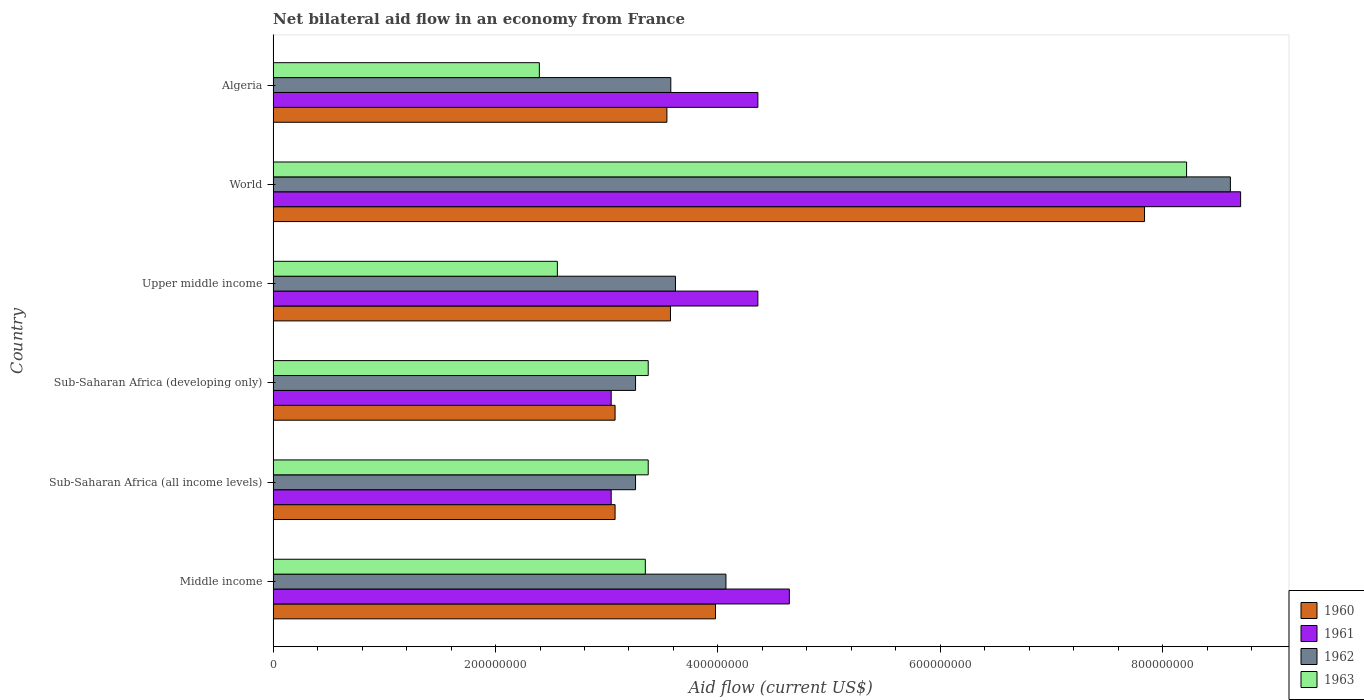How many bars are there on the 6th tick from the top?
Offer a very short reply. 4. How many bars are there on the 5th tick from the bottom?
Keep it short and to the point. 4. In how many cases, is the number of bars for a given country not equal to the number of legend labels?
Your response must be concise. 0. What is the net bilateral aid flow in 1960 in World?
Provide a succinct answer. 7.84e+08. Across all countries, what is the maximum net bilateral aid flow in 1963?
Offer a terse response. 8.21e+08. Across all countries, what is the minimum net bilateral aid flow in 1961?
Your response must be concise. 3.04e+08. In which country was the net bilateral aid flow in 1961 maximum?
Offer a terse response. World. In which country was the net bilateral aid flow in 1962 minimum?
Offer a very short reply. Sub-Saharan Africa (all income levels). What is the total net bilateral aid flow in 1962 in the graph?
Keep it short and to the point. 2.64e+09. What is the difference between the net bilateral aid flow in 1963 in Algeria and that in Upper middle income?
Your response must be concise. -1.62e+07. What is the difference between the net bilateral aid flow in 1960 in Sub-Saharan Africa (all income levels) and the net bilateral aid flow in 1962 in Middle income?
Offer a very short reply. -9.97e+07. What is the average net bilateral aid flow in 1962 per country?
Give a very brief answer. 4.40e+08. What is the difference between the net bilateral aid flow in 1960 and net bilateral aid flow in 1963 in Sub-Saharan Africa (all income levels)?
Your answer should be very brief. -2.98e+07. In how many countries, is the net bilateral aid flow in 1962 greater than 160000000 US$?
Make the answer very short. 6. What is the ratio of the net bilateral aid flow in 1961 in Sub-Saharan Africa (developing only) to that in Upper middle income?
Provide a short and direct response. 0.7. Is the difference between the net bilateral aid flow in 1960 in Middle income and Sub-Saharan Africa (all income levels) greater than the difference between the net bilateral aid flow in 1963 in Middle income and Sub-Saharan Africa (all income levels)?
Provide a succinct answer. Yes. What is the difference between the highest and the second highest net bilateral aid flow in 1960?
Give a very brief answer. 3.86e+08. What is the difference between the highest and the lowest net bilateral aid flow in 1961?
Offer a terse response. 5.66e+08. Is the sum of the net bilateral aid flow in 1961 in Middle income and World greater than the maximum net bilateral aid flow in 1963 across all countries?
Your answer should be very brief. Yes. Is it the case that in every country, the sum of the net bilateral aid flow in 1962 and net bilateral aid flow in 1960 is greater than the sum of net bilateral aid flow in 1963 and net bilateral aid flow in 1961?
Offer a terse response. No. What does the 4th bar from the top in Middle income represents?
Provide a succinct answer. 1960. What does the 3rd bar from the bottom in Sub-Saharan Africa (developing only) represents?
Your answer should be very brief. 1962. Is it the case that in every country, the sum of the net bilateral aid flow in 1961 and net bilateral aid flow in 1962 is greater than the net bilateral aid flow in 1963?
Make the answer very short. Yes. Are all the bars in the graph horizontal?
Give a very brief answer. Yes. How many countries are there in the graph?
Your answer should be compact. 6. Does the graph contain any zero values?
Your answer should be very brief. No. Does the graph contain grids?
Make the answer very short. No. How many legend labels are there?
Offer a very short reply. 4. What is the title of the graph?
Provide a succinct answer. Net bilateral aid flow in an economy from France. Does "2009" appear as one of the legend labels in the graph?
Offer a terse response. No. What is the Aid flow (current US$) of 1960 in Middle income?
Keep it short and to the point. 3.98e+08. What is the Aid flow (current US$) in 1961 in Middle income?
Your response must be concise. 4.64e+08. What is the Aid flow (current US$) in 1962 in Middle income?
Offer a terse response. 4.07e+08. What is the Aid flow (current US$) of 1963 in Middle income?
Provide a short and direct response. 3.35e+08. What is the Aid flow (current US$) in 1960 in Sub-Saharan Africa (all income levels)?
Your answer should be very brief. 3.08e+08. What is the Aid flow (current US$) in 1961 in Sub-Saharan Africa (all income levels)?
Your answer should be compact. 3.04e+08. What is the Aid flow (current US$) in 1962 in Sub-Saharan Africa (all income levels)?
Make the answer very short. 3.26e+08. What is the Aid flow (current US$) in 1963 in Sub-Saharan Africa (all income levels)?
Your response must be concise. 3.37e+08. What is the Aid flow (current US$) in 1960 in Sub-Saharan Africa (developing only)?
Keep it short and to the point. 3.08e+08. What is the Aid flow (current US$) in 1961 in Sub-Saharan Africa (developing only)?
Offer a very short reply. 3.04e+08. What is the Aid flow (current US$) of 1962 in Sub-Saharan Africa (developing only)?
Provide a succinct answer. 3.26e+08. What is the Aid flow (current US$) in 1963 in Sub-Saharan Africa (developing only)?
Offer a very short reply. 3.37e+08. What is the Aid flow (current US$) of 1960 in Upper middle income?
Provide a short and direct response. 3.57e+08. What is the Aid flow (current US$) of 1961 in Upper middle income?
Provide a succinct answer. 4.36e+08. What is the Aid flow (current US$) of 1962 in Upper middle income?
Give a very brief answer. 3.62e+08. What is the Aid flow (current US$) in 1963 in Upper middle income?
Your answer should be very brief. 2.56e+08. What is the Aid flow (current US$) in 1960 in World?
Offer a terse response. 7.84e+08. What is the Aid flow (current US$) of 1961 in World?
Provide a succinct answer. 8.70e+08. What is the Aid flow (current US$) of 1962 in World?
Offer a very short reply. 8.61e+08. What is the Aid flow (current US$) of 1963 in World?
Offer a very short reply. 8.21e+08. What is the Aid flow (current US$) in 1960 in Algeria?
Ensure brevity in your answer.  3.54e+08. What is the Aid flow (current US$) in 1961 in Algeria?
Your answer should be very brief. 4.36e+08. What is the Aid flow (current US$) of 1962 in Algeria?
Give a very brief answer. 3.58e+08. What is the Aid flow (current US$) in 1963 in Algeria?
Keep it short and to the point. 2.39e+08. Across all countries, what is the maximum Aid flow (current US$) of 1960?
Your answer should be very brief. 7.84e+08. Across all countries, what is the maximum Aid flow (current US$) in 1961?
Your answer should be very brief. 8.70e+08. Across all countries, what is the maximum Aid flow (current US$) of 1962?
Your answer should be very brief. 8.61e+08. Across all countries, what is the maximum Aid flow (current US$) of 1963?
Your response must be concise. 8.21e+08. Across all countries, what is the minimum Aid flow (current US$) in 1960?
Offer a terse response. 3.08e+08. Across all countries, what is the minimum Aid flow (current US$) in 1961?
Your answer should be very brief. 3.04e+08. Across all countries, what is the minimum Aid flow (current US$) of 1962?
Make the answer very short. 3.26e+08. Across all countries, what is the minimum Aid flow (current US$) in 1963?
Keep it short and to the point. 2.39e+08. What is the total Aid flow (current US$) in 1960 in the graph?
Keep it short and to the point. 2.51e+09. What is the total Aid flow (current US$) in 1961 in the graph?
Offer a very short reply. 2.81e+09. What is the total Aid flow (current US$) of 1962 in the graph?
Your answer should be very brief. 2.64e+09. What is the total Aid flow (current US$) in 1963 in the graph?
Offer a terse response. 2.33e+09. What is the difference between the Aid flow (current US$) in 1960 in Middle income and that in Sub-Saharan Africa (all income levels)?
Give a very brief answer. 9.03e+07. What is the difference between the Aid flow (current US$) of 1961 in Middle income and that in Sub-Saharan Africa (all income levels)?
Offer a terse response. 1.60e+08. What is the difference between the Aid flow (current US$) of 1962 in Middle income and that in Sub-Saharan Africa (all income levels)?
Ensure brevity in your answer.  8.13e+07. What is the difference between the Aid flow (current US$) of 1963 in Middle income and that in Sub-Saharan Africa (all income levels)?
Offer a terse response. -2.60e+06. What is the difference between the Aid flow (current US$) of 1960 in Middle income and that in Sub-Saharan Africa (developing only)?
Your answer should be compact. 9.03e+07. What is the difference between the Aid flow (current US$) in 1961 in Middle income and that in Sub-Saharan Africa (developing only)?
Provide a short and direct response. 1.60e+08. What is the difference between the Aid flow (current US$) in 1962 in Middle income and that in Sub-Saharan Africa (developing only)?
Offer a terse response. 8.13e+07. What is the difference between the Aid flow (current US$) of 1963 in Middle income and that in Sub-Saharan Africa (developing only)?
Provide a succinct answer. -2.60e+06. What is the difference between the Aid flow (current US$) in 1960 in Middle income and that in Upper middle income?
Provide a short and direct response. 4.05e+07. What is the difference between the Aid flow (current US$) in 1961 in Middle income and that in Upper middle income?
Make the answer very short. 2.83e+07. What is the difference between the Aid flow (current US$) of 1962 in Middle income and that in Upper middle income?
Offer a very short reply. 4.54e+07. What is the difference between the Aid flow (current US$) of 1963 in Middle income and that in Upper middle income?
Your response must be concise. 7.91e+07. What is the difference between the Aid flow (current US$) in 1960 in Middle income and that in World?
Your answer should be compact. -3.86e+08. What is the difference between the Aid flow (current US$) of 1961 in Middle income and that in World?
Provide a succinct answer. -4.06e+08. What is the difference between the Aid flow (current US$) of 1962 in Middle income and that in World?
Give a very brief answer. -4.54e+08. What is the difference between the Aid flow (current US$) of 1963 in Middle income and that in World?
Your answer should be compact. -4.87e+08. What is the difference between the Aid flow (current US$) in 1960 in Middle income and that in Algeria?
Your answer should be compact. 4.37e+07. What is the difference between the Aid flow (current US$) of 1961 in Middle income and that in Algeria?
Keep it short and to the point. 2.83e+07. What is the difference between the Aid flow (current US$) in 1962 in Middle income and that in Algeria?
Provide a short and direct response. 4.96e+07. What is the difference between the Aid flow (current US$) in 1963 in Middle income and that in Algeria?
Give a very brief answer. 9.53e+07. What is the difference between the Aid flow (current US$) of 1960 in Sub-Saharan Africa (all income levels) and that in Sub-Saharan Africa (developing only)?
Make the answer very short. 0. What is the difference between the Aid flow (current US$) of 1960 in Sub-Saharan Africa (all income levels) and that in Upper middle income?
Make the answer very short. -4.98e+07. What is the difference between the Aid flow (current US$) of 1961 in Sub-Saharan Africa (all income levels) and that in Upper middle income?
Your response must be concise. -1.32e+08. What is the difference between the Aid flow (current US$) of 1962 in Sub-Saharan Africa (all income levels) and that in Upper middle income?
Offer a terse response. -3.59e+07. What is the difference between the Aid flow (current US$) of 1963 in Sub-Saharan Africa (all income levels) and that in Upper middle income?
Your answer should be compact. 8.17e+07. What is the difference between the Aid flow (current US$) in 1960 in Sub-Saharan Africa (all income levels) and that in World?
Offer a terse response. -4.76e+08. What is the difference between the Aid flow (current US$) of 1961 in Sub-Saharan Africa (all income levels) and that in World?
Offer a very short reply. -5.66e+08. What is the difference between the Aid flow (current US$) in 1962 in Sub-Saharan Africa (all income levels) and that in World?
Offer a very short reply. -5.35e+08. What is the difference between the Aid flow (current US$) of 1963 in Sub-Saharan Africa (all income levels) and that in World?
Give a very brief answer. -4.84e+08. What is the difference between the Aid flow (current US$) of 1960 in Sub-Saharan Africa (all income levels) and that in Algeria?
Make the answer very short. -4.66e+07. What is the difference between the Aid flow (current US$) in 1961 in Sub-Saharan Africa (all income levels) and that in Algeria?
Provide a short and direct response. -1.32e+08. What is the difference between the Aid flow (current US$) of 1962 in Sub-Saharan Africa (all income levels) and that in Algeria?
Your answer should be compact. -3.17e+07. What is the difference between the Aid flow (current US$) of 1963 in Sub-Saharan Africa (all income levels) and that in Algeria?
Offer a very short reply. 9.79e+07. What is the difference between the Aid flow (current US$) in 1960 in Sub-Saharan Africa (developing only) and that in Upper middle income?
Keep it short and to the point. -4.98e+07. What is the difference between the Aid flow (current US$) in 1961 in Sub-Saharan Africa (developing only) and that in Upper middle income?
Provide a succinct answer. -1.32e+08. What is the difference between the Aid flow (current US$) in 1962 in Sub-Saharan Africa (developing only) and that in Upper middle income?
Keep it short and to the point. -3.59e+07. What is the difference between the Aid flow (current US$) in 1963 in Sub-Saharan Africa (developing only) and that in Upper middle income?
Your answer should be very brief. 8.17e+07. What is the difference between the Aid flow (current US$) of 1960 in Sub-Saharan Africa (developing only) and that in World?
Ensure brevity in your answer.  -4.76e+08. What is the difference between the Aid flow (current US$) in 1961 in Sub-Saharan Africa (developing only) and that in World?
Make the answer very short. -5.66e+08. What is the difference between the Aid flow (current US$) in 1962 in Sub-Saharan Africa (developing only) and that in World?
Your answer should be compact. -5.35e+08. What is the difference between the Aid flow (current US$) in 1963 in Sub-Saharan Africa (developing only) and that in World?
Offer a terse response. -4.84e+08. What is the difference between the Aid flow (current US$) of 1960 in Sub-Saharan Africa (developing only) and that in Algeria?
Provide a short and direct response. -4.66e+07. What is the difference between the Aid flow (current US$) in 1961 in Sub-Saharan Africa (developing only) and that in Algeria?
Your response must be concise. -1.32e+08. What is the difference between the Aid flow (current US$) in 1962 in Sub-Saharan Africa (developing only) and that in Algeria?
Offer a terse response. -3.17e+07. What is the difference between the Aid flow (current US$) in 1963 in Sub-Saharan Africa (developing only) and that in Algeria?
Make the answer very short. 9.79e+07. What is the difference between the Aid flow (current US$) of 1960 in Upper middle income and that in World?
Make the answer very short. -4.26e+08. What is the difference between the Aid flow (current US$) in 1961 in Upper middle income and that in World?
Your response must be concise. -4.34e+08. What is the difference between the Aid flow (current US$) of 1962 in Upper middle income and that in World?
Provide a succinct answer. -4.99e+08. What is the difference between the Aid flow (current US$) of 1963 in Upper middle income and that in World?
Ensure brevity in your answer.  -5.66e+08. What is the difference between the Aid flow (current US$) of 1960 in Upper middle income and that in Algeria?
Offer a terse response. 3.20e+06. What is the difference between the Aid flow (current US$) of 1961 in Upper middle income and that in Algeria?
Provide a succinct answer. 0. What is the difference between the Aid flow (current US$) in 1962 in Upper middle income and that in Algeria?
Your answer should be compact. 4.20e+06. What is the difference between the Aid flow (current US$) in 1963 in Upper middle income and that in Algeria?
Make the answer very short. 1.62e+07. What is the difference between the Aid flow (current US$) of 1960 in World and that in Algeria?
Your answer should be very brief. 4.30e+08. What is the difference between the Aid flow (current US$) in 1961 in World and that in Algeria?
Your response must be concise. 4.34e+08. What is the difference between the Aid flow (current US$) of 1962 in World and that in Algeria?
Keep it short and to the point. 5.03e+08. What is the difference between the Aid flow (current US$) of 1963 in World and that in Algeria?
Offer a very short reply. 5.82e+08. What is the difference between the Aid flow (current US$) of 1960 in Middle income and the Aid flow (current US$) of 1961 in Sub-Saharan Africa (all income levels)?
Provide a succinct answer. 9.38e+07. What is the difference between the Aid flow (current US$) in 1960 in Middle income and the Aid flow (current US$) in 1962 in Sub-Saharan Africa (all income levels)?
Offer a terse response. 7.19e+07. What is the difference between the Aid flow (current US$) of 1960 in Middle income and the Aid flow (current US$) of 1963 in Sub-Saharan Africa (all income levels)?
Offer a very short reply. 6.05e+07. What is the difference between the Aid flow (current US$) in 1961 in Middle income and the Aid flow (current US$) in 1962 in Sub-Saharan Africa (all income levels)?
Your response must be concise. 1.38e+08. What is the difference between the Aid flow (current US$) of 1961 in Middle income and the Aid flow (current US$) of 1963 in Sub-Saharan Africa (all income levels)?
Offer a very short reply. 1.27e+08. What is the difference between the Aid flow (current US$) in 1962 in Middle income and the Aid flow (current US$) in 1963 in Sub-Saharan Africa (all income levels)?
Your answer should be very brief. 6.99e+07. What is the difference between the Aid flow (current US$) of 1960 in Middle income and the Aid flow (current US$) of 1961 in Sub-Saharan Africa (developing only)?
Provide a short and direct response. 9.38e+07. What is the difference between the Aid flow (current US$) in 1960 in Middle income and the Aid flow (current US$) in 1962 in Sub-Saharan Africa (developing only)?
Offer a very short reply. 7.19e+07. What is the difference between the Aid flow (current US$) in 1960 in Middle income and the Aid flow (current US$) in 1963 in Sub-Saharan Africa (developing only)?
Make the answer very short. 6.05e+07. What is the difference between the Aid flow (current US$) in 1961 in Middle income and the Aid flow (current US$) in 1962 in Sub-Saharan Africa (developing only)?
Provide a succinct answer. 1.38e+08. What is the difference between the Aid flow (current US$) of 1961 in Middle income and the Aid flow (current US$) of 1963 in Sub-Saharan Africa (developing only)?
Offer a very short reply. 1.27e+08. What is the difference between the Aid flow (current US$) of 1962 in Middle income and the Aid flow (current US$) of 1963 in Sub-Saharan Africa (developing only)?
Ensure brevity in your answer.  6.99e+07. What is the difference between the Aid flow (current US$) in 1960 in Middle income and the Aid flow (current US$) in 1961 in Upper middle income?
Your response must be concise. -3.81e+07. What is the difference between the Aid flow (current US$) in 1960 in Middle income and the Aid flow (current US$) in 1962 in Upper middle income?
Give a very brief answer. 3.60e+07. What is the difference between the Aid flow (current US$) in 1960 in Middle income and the Aid flow (current US$) in 1963 in Upper middle income?
Your answer should be compact. 1.42e+08. What is the difference between the Aid flow (current US$) in 1961 in Middle income and the Aid flow (current US$) in 1962 in Upper middle income?
Your answer should be compact. 1.02e+08. What is the difference between the Aid flow (current US$) in 1961 in Middle income and the Aid flow (current US$) in 1963 in Upper middle income?
Your response must be concise. 2.09e+08. What is the difference between the Aid flow (current US$) in 1962 in Middle income and the Aid flow (current US$) in 1963 in Upper middle income?
Your answer should be compact. 1.52e+08. What is the difference between the Aid flow (current US$) of 1960 in Middle income and the Aid flow (current US$) of 1961 in World?
Provide a succinct answer. -4.72e+08. What is the difference between the Aid flow (current US$) in 1960 in Middle income and the Aid flow (current US$) in 1962 in World?
Keep it short and to the point. -4.63e+08. What is the difference between the Aid flow (current US$) in 1960 in Middle income and the Aid flow (current US$) in 1963 in World?
Give a very brief answer. -4.24e+08. What is the difference between the Aid flow (current US$) of 1961 in Middle income and the Aid flow (current US$) of 1962 in World?
Offer a very short reply. -3.97e+08. What is the difference between the Aid flow (current US$) of 1961 in Middle income and the Aid flow (current US$) of 1963 in World?
Give a very brief answer. -3.57e+08. What is the difference between the Aid flow (current US$) in 1962 in Middle income and the Aid flow (current US$) in 1963 in World?
Offer a terse response. -4.14e+08. What is the difference between the Aid flow (current US$) in 1960 in Middle income and the Aid flow (current US$) in 1961 in Algeria?
Your response must be concise. -3.81e+07. What is the difference between the Aid flow (current US$) in 1960 in Middle income and the Aid flow (current US$) in 1962 in Algeria?
Give a very brief answer. 4.02e+07. What is the difference between the Aid flow (current US$) in 1960 in Middle income and the Aid flow (current US$) in 1963 in Algeria?
Ensure brevity in your answer.  1.58e+08. What is the difference between the Aid flow (current US$) of 1961 in Middle income and the Aid flow (current US$) of 1962 in Algeria?
Your response must be concise. 1.07e+08. What is the difference between the Aid flow (current US$) of 1961 in Middle income and the Aid flow (current US$) of 1963 in Algeria?
Provide a short and direct response. 2.25e+08. What is the difference between the Aid flow (current US$) of 1962 in Middle income and the Aid flow (current US$) of 1963 in Algeria?
Ensure brevity in your answer.  1.68e+08. What is the difference between the Aid flow (current US$) in 1960 in Sub-Saharan Africa (all income levels) and the Aid flow (current US$) in 1961 in Sub-Saharan Africa (developing only)?
Your response must be concise. 3.50e+06. What is the difference between the Aid flow (current US$) of 1960 in Sub-Saharan Africa (all income levels) and the Aid flow (current US$) of 1962 in Sub-Saharan Africa (developing only)?
Your answer should be compact. -1.84e+07. What is the difference between the Aid flow (current US$) in 1960 in Sub-Saharan Africa (all income levels) and the Aid flow (current US$) in 1963 in Sub-Saharan Africa (developing only)?
Provide a succinct answer. -2.98e+07. What is the difference between the Aid flow (current US$) in 1961 in Sub-Saharan Africa (all income levels) and the Aid flow (current US$) in 1962 in Sub-Saharan Africa (developing only)?
Your answer should be compact. -2.19e+07. What is the difference between the Aid flow (current US$) in 1961 in Sub-Saharan Africa (all income levels) and the Aid flow (current US$) in 1963 in Sub-Saharan Africa (developing only)?
Ensure brevity in your answer.  -3.33e+07. What is the difference between the Aid flow (current US$) of 1962 in Sub-Saharan Africa (all income levels) and the Aid flow (current US$) of 1963 in Sub-Saharan Africa (developing only)?
Your answer should be very brief. -1.14e+07. What is the difference between the Aid flow (current US$) in 1960 in Sub-Saharan Africa (all income levels) and the Aid flow (current US$) in 1961 in Upper middle income?
Give a very brief answer. -1.28e+08. What is the difference between the Aid flow (current US$) of 1960 in Sub-Saharan Africa (all income levels) and the Aid flow (current US$) of 1962 in Upper middle income?
Your answer should be very brief. -5.43e+07. What is the difference between the Aid flow (current US$) in 1960 in Sub-Saharan Africa (all income levels) and the Aid flow (current US$) in 1963 in Upper middle income?
Give a very brief answer. 5.19e+07. What is the difference between the Aid flow (current US$) of 1961 in Sub-Saharan Africa (all income levels) and the Aid flow (current US$) of 1962 in Upper middle income?
Your answer should be compact. -5.78e+07. What is the difference between the Aid flow (current US$) of 1961 in Sub-Saharan Africa (all income levels) and the Aid flow (current US$) of 1963 in Upper middle income?
Give a very brief answer. 4.84e+07. What is the difference between the Aid flow (current US$) in 1962 in Sub-Saharan Africa (all income levels) and the Aid flow (current US$) in 1963 in Upper middle income?
Your response must be concise. 7.03e+07. What is the difference between the Aid flow (current US$) in 1960 in Sub-Saharan Africa (all income levels) and the Aid flow (current US$) in 1961 in World?
Make the answer very short. -5.62e+08. What is the difference between the Aid flow (current US$) in 1960 in Sub-Saharan Africa (all income levels) and the Aid flow (current US$) in 1962 in World?
Your answer should be very brief. -5.53e+08. What is the difference between the Aid flow (current US$) of 1960 in Sub-Saharan Africa (all income levels) and the Aid flow (current US$) of 1963 in World?
Keep it short and to the point. -5.14e+08. What is the difference between the Aid flow (current US$) in 1961 in Sub-Saharan Africa (all income levels) and the Aid flow (current US$) in 1962 in World?
Your response must be concise. -5.57e+08. What is the difference between the Aid flow (current US$) in 1961 in Sub-Saharan Africa (all income levels) and the Aid flow (current US$) in 1963 in World?
Your response must be concise. -5.17e+08. What is the difference between the Aid flow (current US$) of 1962 in Sub-Saharan Africa (all income levels) and the Aid flow (current US$) of 1963 in World?
Make the answer very short. -4.96e+08. What is the difference between the Aid flow (current US$) in 1960 in Sub-Saharan Africa (all income levels) and the Aid flow (current US$) in 1961 in Algeria?
Keep it short and to the point. -1.28e+08. What is the difference between the Aid flow (current US$) of 1960 in Sub-Saharan Africa (all income levels) and the Aid flow (current US$) of 1962 in Algeria?
Ensure brevity in your answer.  -5.01e+07. What is the difference between the Aid flow (current US$) of 1960 in Sub-Saharan Africa (all income levels) and the Aid flow (current US$) of 1963 in Algeria?
Your answer should be very brief. 6.81e+07. What is the difference between the Aid flow (current US$) in 1961 in Sub-Saharan Africa (all income levels) and the Aid flow (current US$) in 1962 in Algeria?
Provide a succinct answer. -5.36e+07. What is the difference between the Aid flow (current US$) of 1961 in Sub-Saharan Africa (all income levels) and the Aid flow (current US$) of 1963 in Algeria?
Your response must be concise. 6.46e+07. What is the difference between the Aid flow (current US$) of 1962 in Sub-Saharan Africa (all income levels) and the Aid flow (current US$) of 1963 in Algeria?
Your answer should be compact. 8.65e+07. What is the difference between the Aid flow (current US$) in 1960 in Sub-Saharan Africa (developing only) and the Aid flow (current US$) in 1961 in Upper middle income?
Keep it short and to the point. -1.28e+08. What is the difference between the Aid flow (current US$) in 1960 in Sub-Saharan Africa (developing only) and the Aid flow (current US$) in 1962 in Upper middle income?
Offer a terse response. -5.43e+07. What is the difference between the Aid flow (current US$) in 1960 in Sub-Saharan Africa (developing only) and the Aid flow (current US$) in 1963 in Upper middle income?
Keep it short and to the point. 5.19e+07. What is the difference between the Aid flow (current US$) in 1961 in Sub-Saharan Africa (developing only) and the Aid flow (current US$) in 1962 in Upper middle income?
Keep it short and to the point. -5.78e+07. What is the difference between the Aid flow (current US$) of 1961 in Sub-Saharan Africa (developing only) and the Aid flow (current US$) of 1963 in Upper middle income?
Make the answer very short. 4.84e+07. What is the difference between the Aid flow (current US$) in 1962 in Sub-Saharan Africa (developing only) and the Aid flow (current US$) in 1963 in Upper middle income?
Provide a succinct answer. 7.03e+07. What is the difference between the Aid flow (current US$) of 1960 in Sub-Saharan Africa (developing only) and the Aid flow (current US$) of 1961 in World?
Your answer should be very brief. -5.62e+08. What is the difference between the Aid flow (current US$) of 1960 in Sub-Saharan Africa (developing only) and the Aid flow (current US$) of 1962 in World?
Provide a succinct answer. -5.53e+08. What is the difference between the Aid flow (current US$) of 1960 in Sub-Saharan Africa (developing only) and the Aid flow (current US$) of 1963 in World?
Offer a terse response. -5.14e+08. What is the difference between the Aid flow (current US$) in 1961 in Sub-Saharan Africa (developing only) and the Aid flow (current US$) in 1962 in World?
Offer a very short reply. -5.57e+08. What is the difference between the Aid flow (current US$) in 1961 in Sub-Saharan Africa (developing only) and the Aid flow (current US$) in 1963 in World?
Offer a very short reply. -5.17e+08. What is the difference between the Aid flow (current US$) of 1962 in Sub-Saharan Africa (developing only) and the Aid flow (current US$) of 1963 in World?
Ensure brevity in your answer.  -4.96e+08. What is the difference between the Aid flow (current US$) of 1960 in Sub-Saharan Africa (developing only) and the Aid flow (current US$) of 1961 in Algeria?
Give a very brief answer. -1.28e+08. What is the difference between the Aid flow (current US$) of 1960 in Sub-Saharan Africa (developing only) and the Aid flow (current US$) of 1962 in Algeria?
Your response must be concise. -5.01e+07. What is the difference between the Aid flow (current US$) in 1960 in Sub-Saharan Africa (developing only) and the Aid flow (current US$) in 1963 in Algeria?
Offer a terse response. 6.81e+07. What is the difference between the Aid flow (current US$) of 1961 in Sub-Saharan Africa (developing only) and the Aid flow (current US$) of 1962 in Algeria?
Your answer should be compact. -5.36e+07. What is the difference between the Aid flow (current US$) in 1961 in Sub-Saharan Africa (developing only) and the Aid flow (current US$) in 1963 in Algeria?
Offer a very short reply. 6.46e+07. What is the difference between the Aid flow (current US$) of 1962 in Sub-Saharan Africa (developing only) and the Aid flow (current US$) of 1963 in Algeria?
Offer a very short reply. 8.65e+07. What is the difference between the Aid flow (current US$) of 1960 in Upper middle income and the Aid flow (current US$) of 1961 in World?
Provide a succinct answer. -5.13e+08. What is the difference between the Aid flow (current US$) in 1960 in Upper middle income and the Aid flow (current US$) in 1962 in World?
Keep it short and to the point. -5.04e+08. What is the difference between the Aid flow (current US$) in 1960 in Upper middle income and the Aid flow (current US$) in 1963 in World?
Make the answer very short. -4.64e+08. What is the difference between the Aid flow (current US$) in 1961 in Upper middle income and the Aid flow (current US$) in 1962 in World?
Provide a short and direct response. -4.25e+08. What is the difference between the Aid flow (current US$) of 1961 in Upper middle income and the Aid flow (current US$) of 1963 in World?
Keep it short and to the point. -3.86e+08. What is the difference between the Aid flow (current US$) in 1962 in Upper middle income and the Aid flow (current US$) in 1963 in World?
Offer a very short reply. -4.60e+08. What is the difference between the Aid flow (current US$) of 1960 in Upper middle income and the Aid flow (current US$) of 1961 in Algeria?
Provide a short and direct response. -7.86e+07. What is the difference between the Aid flow (current US$) of 1960 in Upper middle income and the Aid flow (current US$) of 1962 in Algeria?
Your response must be concise. -3.00e+05. What is the difference between the Aid flow (current US$) in 1960 in Upper middle income and the Aid flow (current US$) in 1963 in Algeria?
Your answer should be compact. 1.18e+08. What is the difference between the Aid flow (current US$) in 1961 in Upper middle income and the Aid flow (current US$) in 1962 in Algeria?
Offer a very short reply. 7.83e+07. What is the difference between the Aid flow (current US$) of 1961 in Upper middle income and the Aid flow (current US$) of 1963 in Algeria?
Make the answer very short. 1.96e+08. What is the difference between the Aid flow (current US$) of 1962 in Upper middle income and the Aid flow (current US$) of 1963 in Algeria?
Your response must be concise. 1.22e+08. What is the difference between the Aid flow (current US$) in 1960 in World and the Aid flow (current US$) in 1961 in Algeria?
Keep it short and to the point. 3.48e+08. What is the difference between the Aid flow (current US$) of 1960 in World and the Aid flow (current US$) of 1962 in Algeria?
Provide a short and direct response. 4.26e+08. What is the difference between the Aid flow (current US$) of 1960 in World and the Aid flow (current US$) of 1963 in Algeria?
Provide a succinct answer. 5.44e+08. What is the difference between the Aid flow (current US$) of 1961 in World and the Aid flow (current US$) of 1962 in Algeria?
Provide a succinct answer. 5.12e+08. What is the difference between the Aid flow (current US$) in 1961 in World and the Aid flow (current US$) in 1963 in Algeria?
Provide a succinct answer. 6.31e+08. What is the difference between the Aid flow (current US$) of 1962 in World and the Aid flow (current US$) of 1963 in Algeria?
Offer a terse response. 6.21e+08. What is the average Aid flow (current US$) in 1960 per country?
Keep it short and to the point. 4.18e+08. What is the average Aid flow (current US$) in 1961 per country?
Your answer should be compact. 4.69e+08. What is the average Aid flow (current US$) of 1962 per country?
Ensure brevity in your answer.  4.40e+08. What is the average Aid flow (current US$) in 1963 per country?
Provide a short and direct response. 3.88e+08. What is the difference between the Aid flow (current US$) in 1960 and Aid flow (current US$) in 1961 in Middle income?
Ensure brevity in your answer.  -6.64e+07. What is the difference between the Aid flow (current US$) of 1960 and Aid flow (current US$) of 1962 in Middle income?
Offer a very short reply. -9.40e+06. What is the difference between the Aid flow (current US$) in 1960 and Aid flow (current US$) in 1963 in Middle income?
Your response must be concise. 6.31e+07. What is the difference between the Aid flow (current US$) in 1961 and Aid flow (current US$) in 1962 in Middle income?
Offer a terse response. 5.70e+07. What is the difference between the Aid flow (current US$) of 1961 and Aid flow (current US$) of 1963 in Middle income?
Give a very brief answer. 1.30e+08. What is the difference between the Aid flow (current US$) in 1962 and Aid flow (current US$) in 1963 in Middle income?
Provide a succinct answer. 7.25e+07. What is the difference between the Aid flow (current US$) of 1960 and Aid flow (current US$) of 1961 in Sub-Saharan Africa (all income levels)?
Make the answer very short. 3.50e+06. What is the difference between the Aid flow (current US$) in 1960 and Aid flow (current US$) in 1962 in Sub-Saharan Africa (all income levels)?
Your answer should be compact. -1.84e+07. What is the difference between the Aid flow (current US$) of 1960 and Aid flow (current US$) of 1963 in Sub-Saharan Africa (all income levels)?
Make the answer very short. -2.98e+07. What is the difference between the Aid flow (current US$) in 1961 and Aid flow (current US$) in 1962 in Sub-Saharan Africa (all income levels)?
Provide a short and direct response. -2.19e+07. What is the difference between the Aid flow (current US$) of 1961 and Aid flow (current US$) of 1963 in Sub-Saharan Africa (all income levels)?
Make the answer very short. -3.33e+07. What is the difference between the Aid flow (current US$) of 1962 and Aid flow (current US$) of 1963 in Sub-Saharan Africa (all income levels)?
Your answer should be compact. -1.14e+07. What is the difference between the Aid flow (current US$) of 1960 and Aid flow (current US$) of 1961 in Sub-Saharan Africa (developing only)?
Your response must be concise. 3.50e+06. What is the difference between the Aid flow (current US$) of 1960 and Aid flow (current US$) of 1962 in Sub-Saharan Africa (developing only)?
Ensure brevity in your answer.  -1.84e+07. What is the difference between the Aid flow (current US$) of 1960 and Aid flow (current US$) of 1963 in Sub-Saharan Africa (developing only)?
Offer a terse response. -2.98e+07. What is the difference between the Aid flow (current US$) of 1961 and Aid flow (current US$) of 1962 in Sub-Saharan Africa (developing only)?
Give a very brief answer. -2.19e+07. What is the difference between the Aid flow (current US$) in 1961 and Aid flow (current US$) in 1963 in Sub-Saharan Africa (developing only)?
Your answer should be compact. -3.33e+07. What is the difference between the Aid flow (current US$) of 1962 and Aid flow (current US$) of 1963 in Sub-Saharan Africa (developing only)?
Offer a terse response. -1.14e+07. What is the difference between the Aid flow (current US$) of 1960 and Aid flow (current US$) of 1961 in Upper middle income?
Provide a short and direct response. -7.86e+07. What is the difference between the Aid flow (current US$) of 1960 and Aid flow (current US$) of 1962 in Upper middle income?
Provide a short and direct response. -4.50e+06. What is the difference between the Aid flow (current US$) in 1960 and Aid flow (current US$) in 1963 in Upper middle income?
Give a very brief answer. 1.02e+08. What is the difference between the Aid flow (current US$) in 1961 and Aid flow (current US$) in 1962 in Upper middle income?
Keep it short and to the point. 7.41e+07. What is the difference between the Aid flow (current US$) of 1961 and Aid flow (current US$) of 1963 in Upper middle income?
Your answer should be very brief. 1.80e+08. What is the difference between the Aid flow (current US$) of 1962 and Aid flow (current US$) of 1963 in Upper middle income?
Provide a short and direct response. 1.06e+08. What is the difference between the Aid flow (current US$) in 1960 and Aid flow (current US$) in 1961 in World?
Your answer should be very brief. -8.64e+07. What is the difference between the Aid flow (current US$) in 1960 and Aid flow (current US$) in 1962 in World?
Keep it short and to the point. -7.72e+07. What is the difference between the Aid flow (current US$) in 1960 and Aid flow (current US$) in 1963 in World?
Give a very brief answer. -3.78e+07. What is the difference between the Aid flow (current US$) of 1961 and Aid flow (current US$) of 1962 in World?
Your answer should be very brief. 9.20e+06. What is the difference between the Aid flow (current US$) of 1961 and Aid flow (current US$) of 1963 in World?
Offer a terse response. 4.86e+07. What is the difference between the Aid flow (current US$) in 1962 and Aid flow (current US$) in 1963 in World?
Your response must be concise. 3.94e+07. What is the difference between the Aid flow (current US$) in 1960 and Aid flow (current US$) in 1961 in Algeria?
Keep it short and to the point. -8.18e+07. What is the difference between the Aid flow (current US$) in 1960 and Aid flow (current US$) in 1962 in Algeria?
Offer a very short reply. -3.50e+06. What is the difference between the Aid flow (current US$) of 1960 and Aid flow (current US$) of 1963 in Algeria?
Make the answer very short. 1.15e+08. What is the difference between the Aid flow (current US$) in 1961 and Aid flow (current US$) in 1962 in Algeria?
Your answer should be compact. 7.83e+07. What is the difference between the Aid flow (current US$) in 1961 and Aid flow (current US$) in 1963 in Algeria?
Your response must be concise. 1.96e+08. What is the difference between the Aid flow (current US$) in 1962 and Aid flow (current US$) in 1963 in Algeria?
Keep it short and to the point. 1.18e+08. What is the ratio of the Aid flow (current US$) in 1960 in Middle income to that in Sub-Saharan Africa (all income levels)?
Offer a very short reply. 1.29. What is the ratio of the Aid flow (current US$) of 1961 in Middle income to that in Sub-Saharan Africa (all income levels)?
Your answer should be very brief. 1.53. What is the ratio of the Aid flow (current US$) in 1962 in Middle income to that in Sub-Saharan Africa (all income levels)?
Make the answer very short. 1.25. What is the ratio of the Aid flow (current US$) of 1960 in Middle income to that in Sub-Saharan Africa (developing only)?
Provide a short and direct response. 1.29. What is the ratio of the Aid flow (current US$) in 1961 in Middle income to that in Sub-Saharan Africa (developing only)?
Offer a very short reply. 1.53. What is the ratio of the Aid flow (current US$) in 1962 in Middle income to that in Sub-Saharan Africa (developing only)?
Provide a short and direct response. 1.25. What is the ratio of the Aid flow (current US$) of 1960 in Middle income to that in Upper middle income?
Provide a succinct answer. 1.11. What is the ratio of the Aid flow (current US$) of 1961 in Middle income to that in Upper middle income?
Offer a very short reply. 1.06. What is the ratio of the Aid flow (current US$) in 1962 in Middle income to that in Upper middle income?
Ensure brevity in your answer.  1.13. What is the ratio of the Aid flow (current US$) in 1963 in Middle income to that in Upper middle income?
Provide a short and direct response. 1.31. What is the ratio of the Aid flow (current US$) in 1960 in Middle income to that in World?
Your response must be concise. 0.51. What is the ratio of the Aid flow (current US$) of 1961 in Middle income to that in World?
Keep it short and to the point. 0.53. What is the ratio of the Aid flow (current US$) of 1962 in Middle income to that in World?
Provide a short and direct response. 0.47. What is the ratio of the Aid flow (current US$) in 1963 in Middle income to that in World?
Provide a short and direct response. 0.41. What is the ratio of the Aid flow (current US$) in 1960 in Middle income to that in Algeria?
Ensure brevity in your answer.  1.12. What is the ratio of the Aid flow (current US$) of 1961 in Middle income to that in Algeria?
Give a very brief answer. 1.06. What is the ratio of the Aid flow (current US$) in 1962 in Middle income to that in Algeria?
Ensure brevity in your answer.  1.14. What is the ratio of the Aid flow (current US$) in 1963 in Middle income to that in Algeria?
Provide a short and direct response. 1.4. What is the ratio of the Aid flow (current US$) of 1960 in Sub-Saharan Africa (all income levels) to that in Sub-Saharan Africa (developing only)?
Ensure brevity in your answer.  1. What is the ratio of the Aid flow (current US$) of 1960 in Sub-Saharan Africa (all income levels) to that in Upper middle income?
Ensure brevity in your answer.  0.86. What is the ratio of the Aid flow (current US$) in 1961 in Sub-Saharan Africa (all income levels) to that in Upper middle income?
Offer a terse response. 0.7. What is the ratio of the Aid flow (current US$) of 1962 in Sub-Saharan Africa (all income levels) to that in Upper middle income?
Give a very brief answer. 0.9. What is the ratio of the Aid flow (current US$) in 1963 in Sub-Saharan Africa (all income levels) to that in Upper middle income?
Make the answer very short. 1.32. What is the ratio of the Aid flow (current US$) of 1960 in Sub-Saharan Africa (all income levels) to that in World?
Ensure brevity in your answer.  0.39. What is the ratio of the Aid flow (current US$) in 1961 in Sub-Saharan Africa (all income levels) to that in World?
Your answer should be very brief. 0.35. What is the ratio of the Aid flow (current US$) in 1962 in Sub-Saharan Africa (all income levels) to that in World?
Your answer should be compact. 0.38. What is the ratio of the Aid flow (current US$) of 1963 in Sub-Saharan Africa (all income levels) to that in World?
Make the answer very short. 0.41. What is the ratio of the Aid flow (current US$) in 1960 in Sub-Saharan Africa (all income levels) to that in Algeria?
Ensure brevity in your answer.  0.87. What is the ratio of the Aid flow (current US$) in 1961 in Sub-Saharan Africa (all income levels) to that in Algeria?
Give a very brief answer. 0.7. What is the ratio of the Aid flow (current US$) of 1962 in Sub-Saharan Africa (all income levels) to that in Algeria?
Offer a terse response. 0.91. What is the ratio of the Aid flow (current US$) of 1963 in Sub-Saharan Africa (all income levels) to that in Algeria?
Offer a terse response. 1.41. What is the ratio of the Aid flow (current US$) in 1960 in Sub-Saharan Africa (developing only) to that in Upper middle income?
Provide a short and direct response. 0.86. What is the ratio of the Aid flow (current US$) in 1961 in Sub-Saharan Africa (developing only) to that in Upper middle income?
Your answer should be compact. 0.7. What is the ratio of the Aid flow (current US$) of 1962 in Sub-Saharan Africa (developing only) to that in Upper middle income?
Your response must be concise. 0.9. What is the ratio of the Aid flow (current US$) of 1963 in Sub-Saharan Africa (developing only) to that in Upper middle income?
Your answer should be compact. 1.32. What is the ratio of the Aid flow (current US$) of 1960 in Sub-Saharan Africa (developing only) to that in World?
Your answer should be compact. 0.39. What is the ratio of the Aid flow (current US$) of 1961 in Sub-Saharan Africa (developing only) to that in World?
Make the answer very short. 0.35. What is the ratio of the Aid flow (current US$) of 1962 in Sub-Saharan Africa (developing only) to that in World?
Provide a short and direct response. 0.38. What is the ratio of the Aid flow (current US$) in 1963 in Sub-Saharan Africa (developing only) to that in World?
Your response must be concise. 0.41. What is the ratio of the Aid flow (current US$) in 1960 in Sub-Saharan Africa (developing only) to that in Algeria?
Provide a short and direct response. 0.87. What is the ratio of the Aid flow (current US$) in 1961 in Sub-Saharan Africa (developing only) to that in Algeria?
Give a very brief answer. 0.7. What is the ratio of the Aid flow (current US$) of 1962 in Sub-Saharan Africa (developing only) to that in Algeria?
Offer a very short reply. 0.91. What is the ratio of the Aid flow (current US$) in 1963 in Sub-Saharan Africa (developing only) to that in Algeria?
Your response must be concise. 1.41. What is the ratio of the Aid flow (current US$) of 1960 in Upper middle income to that in World?
Offer a very short reply. 0.46. What is the ratio of the Aid flow (current US$) of 1961 in Upper middle income to that in World?
Keep it short and to the point. 0.5. What is the ratio of the Aid flow (current US$) of 1962 in Upper middle income to that in World?
Keep it short and to the point. 0.42. What is the ratio of the Aid flow (current US$) of 1963 in Upper middle income to that in World?
Make the answer very short. 0.31. What is the ratio of the Aid flow (current US$) of 1960 in Upper middle income to that in Algeria?
Your answer should be compact. 1.01. What is the ratio of the Aid flow (current US$) in 1961 in Upper middle income to that in Algeria?
Provide a succinct answer. 1. What is the ratio of the Aid flow (current US$) of 1962 in Upper middle income to that in Algeria?
Your answer should be very brief. 1.01. What is the ratio of the Aid flow (current US$) of 1963 in Upper middle income to that in Algeria?
Provide a succinct answer. 1.07. What is the ratio of the Aid flow (current US$) of 1960 in World to that in Algeria?
Ensure brevity in your answer.  2.21. What is the ratio of the Aid flow (current US$) of 1961 in World to that in Algeria?
Make the answer very short. 2. What is the ratio of the Aid flow (current US$) in 1962 in World to that in Algeria?
Keep it short and to the point. 2.41. What is the ratio of the Aid flow (current US$) of 1963 in World to that in Algeria?
Give a very brief answer. 3.43. What is the difference between the highest and the second highest Aid flow (current US$) of 1960?
Give a very brief answer. 3.86e+08. What is the difference between the highest and the second highest Aid flow (current US$) in 1961?
Ensure brevity in your answer.  4.06e+08. What is the difference between the highest and the second highest Aid flow (current US$) in 1962?
Your response must be concise. 4.54e+08. What is the difference between the highest and the second highest Aid flow (current US$) in 1963?
Offer a very short reply. 4.84e+08. What is the difference between the highest and the lowest Aid flow (current US$) of 1960?
Keep it short and to the point. 4.76e+08. What is the difference between the highest and the lowest Aid flow (current US$) in 1961?
Offer a very short reply. 5.66e+08. What is the difference between the highest and the lowest Aid flow (current US$) of 1962?
Make the answer very short. 5.35e+08. What is the difference between the highest and the lowest Aid flow (current US$) of 1963?
Give a very brief answer. 5.82e+08. 